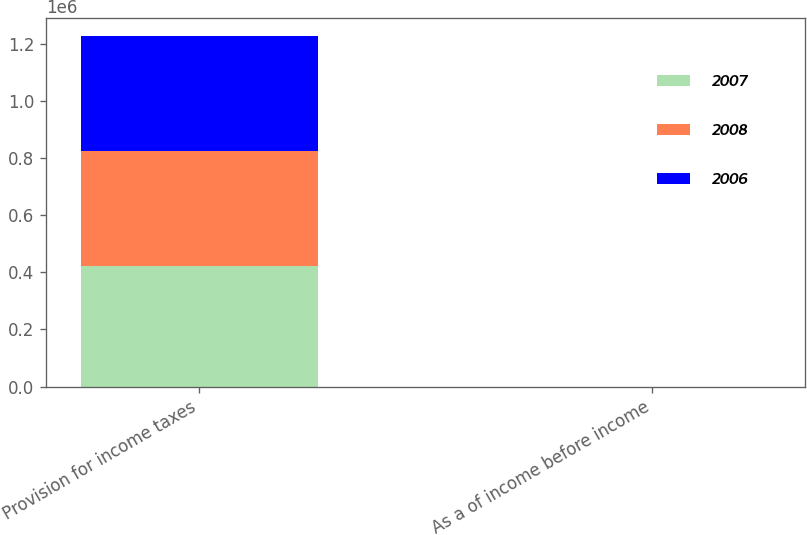Convert chart. <chart><loc_0><loc_0><loc_500><loc_500><stacked_bar_chart><ecel><fcel>Provision for income taxes<fcel>As a of income before income<nl><fcel>2007<fcel>421418<fcel>27<nl><fcel>2008<fcel>402600<fcel>54<nl><fcel>2006<fcel>404090<fcel>19<nl></chart> 